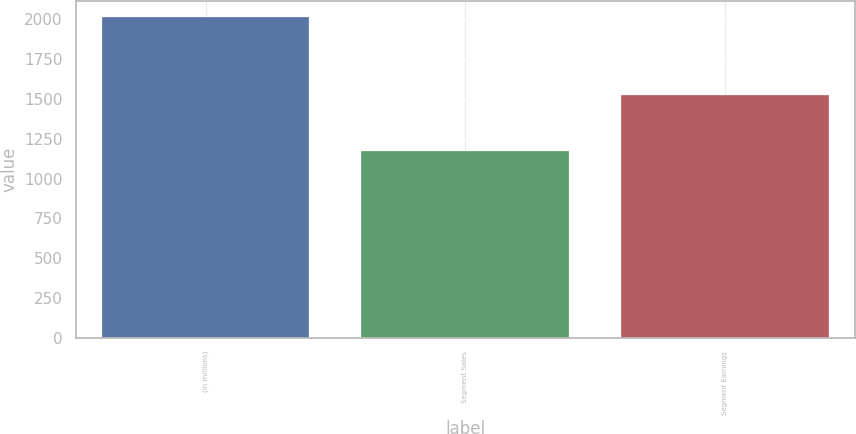Convert chart. <chart><loc_0><loc_0><loc_500><loc_500><bar_chart><fcel>(in millions)<fcel>Segment Sales<fcel>Segment Earnings<nl><fcel>2013<fcel>1174<fcel>1523<nl></chart> 